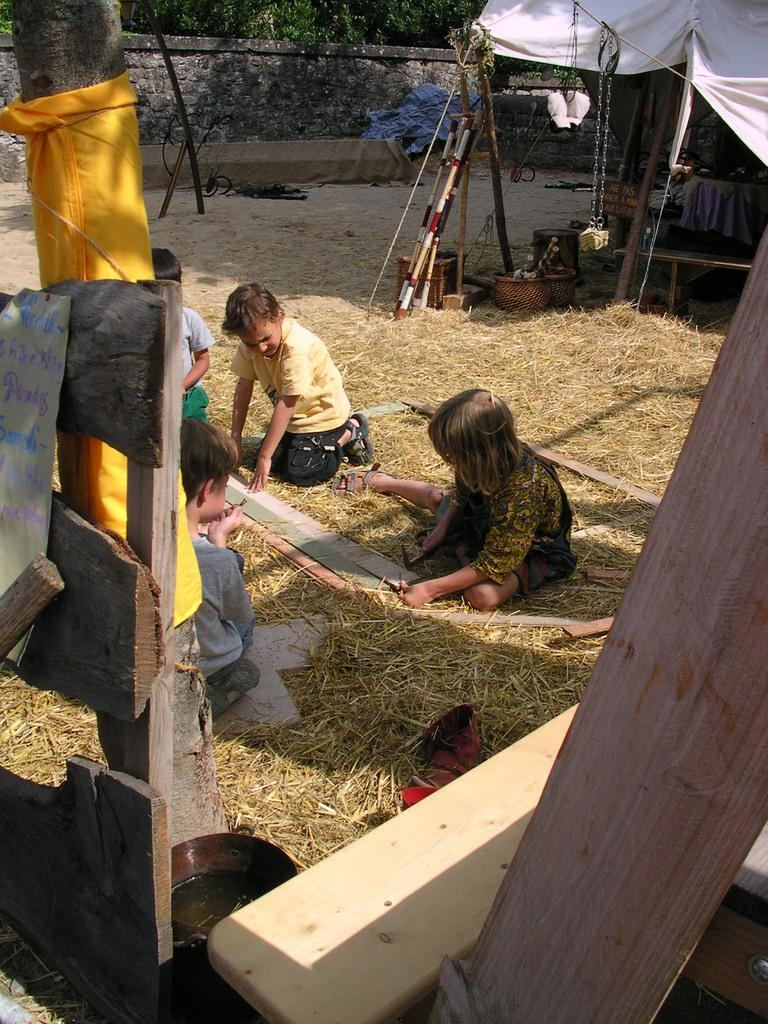What are the people in the image doing? The people in the image are sitting on the dry grass. What type of vegetation is present in the image? There are trees in the image. What objects can be seen in the image besides the trees and people? There are wooden sticks and objects on the ground in the image. What type of structure is visible in the image? There is a wall in the image. What type of door can be seen in the image? There is no door present in the image. What is the tin used for in the image? There is no tin present in the image. 